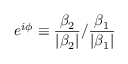<formula> <loc_0><loc_0><loc_500><loc_500>e ^ { i \phi } \equiv \frac { \beta _ { 2 } } { | \beta _ { 2 } | } / \frac { \beta _ { 1 } } { | \beta _ { 1 } | }</formula> 